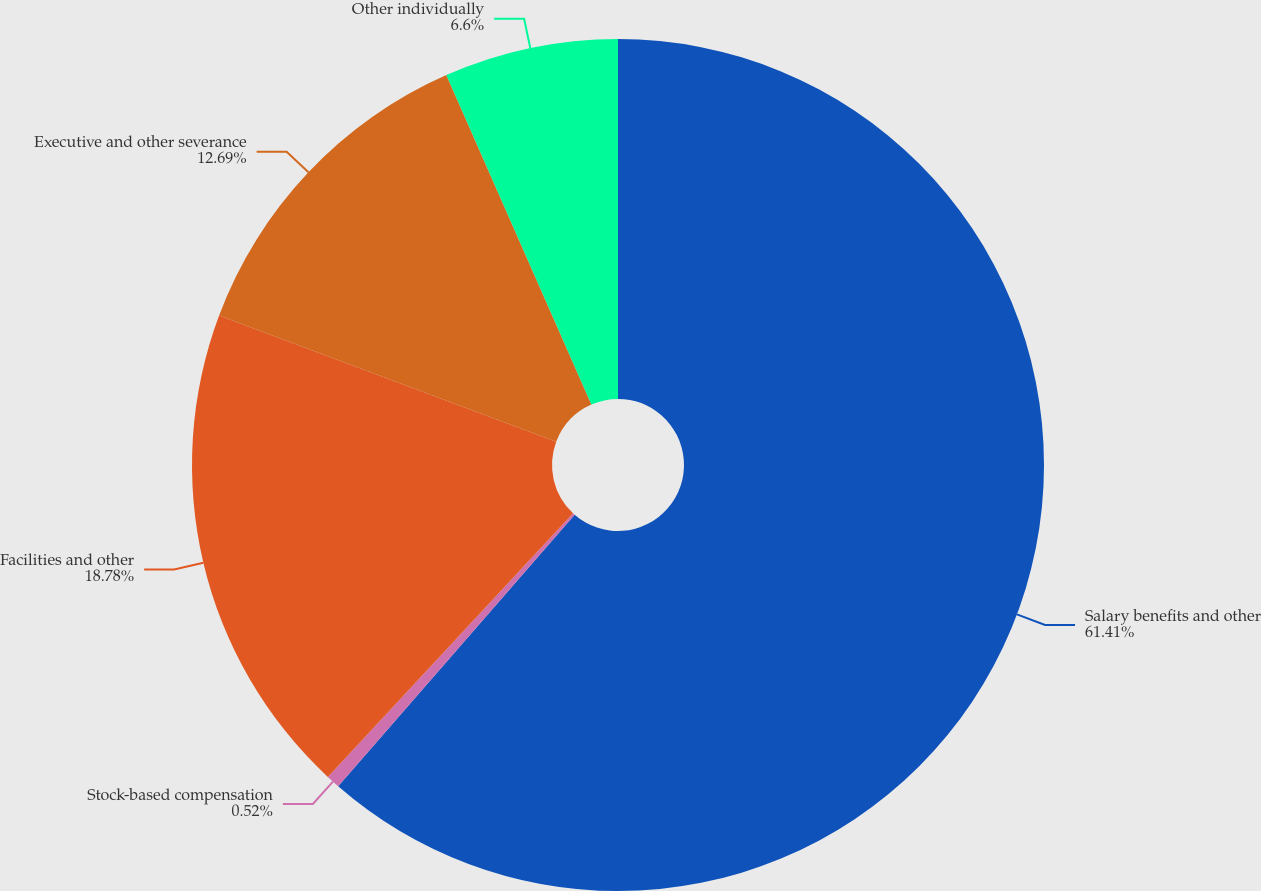<chart> <loc_0><loc_0><loc_500><loc_500><pie_chart><fcel>Salary benefits and other<fcel>Stock-based compensation<fcel>Facilities and other<fcel>Executive and other severance<fcel>Other individually<nl><fcel>61.4%<fcel>0.52%<fcel>18.78%<fcel>12.69%<fcel>6.6%<nl></chart> 